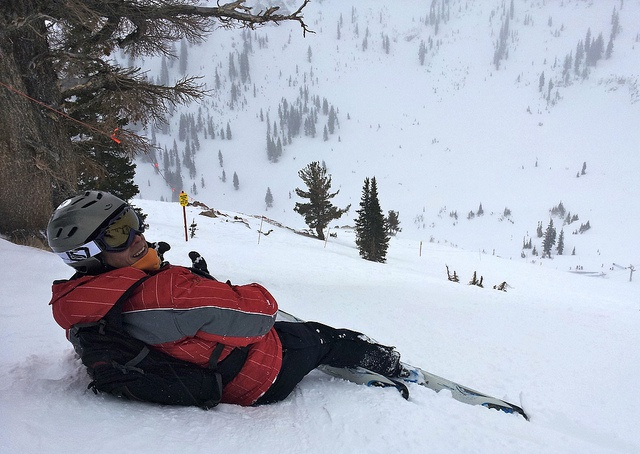Describe the objects in this image and their specific colors. I can see people in black, maroon, lavender, and gray tones, backpack in black, maroon, and gray tones, skis in black, darkgray, gray, and darkblue tones, snowboard in black, darkgray, gray, and lightgray tones, and people in black, darkgray, gray, and lavender tones in this image. 